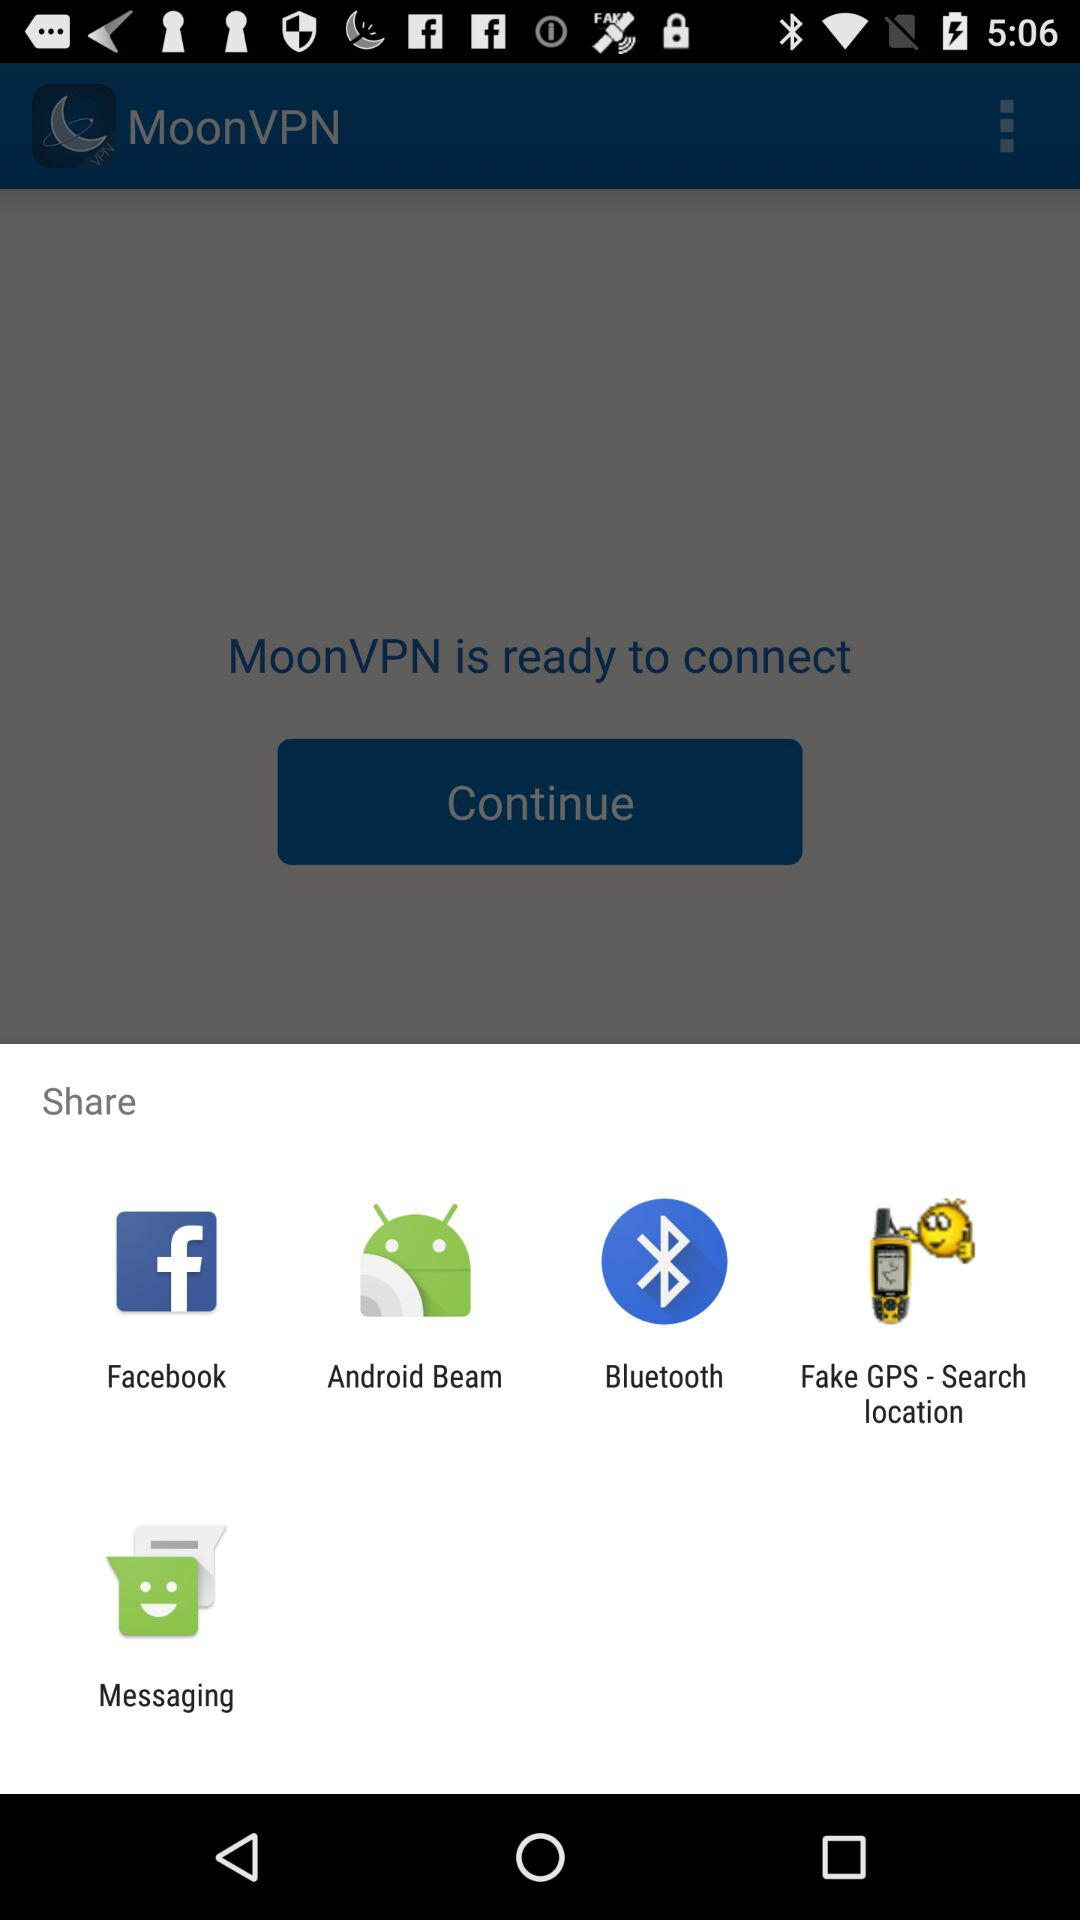What is the name of the application? The name of the application is "MoonVPN". 